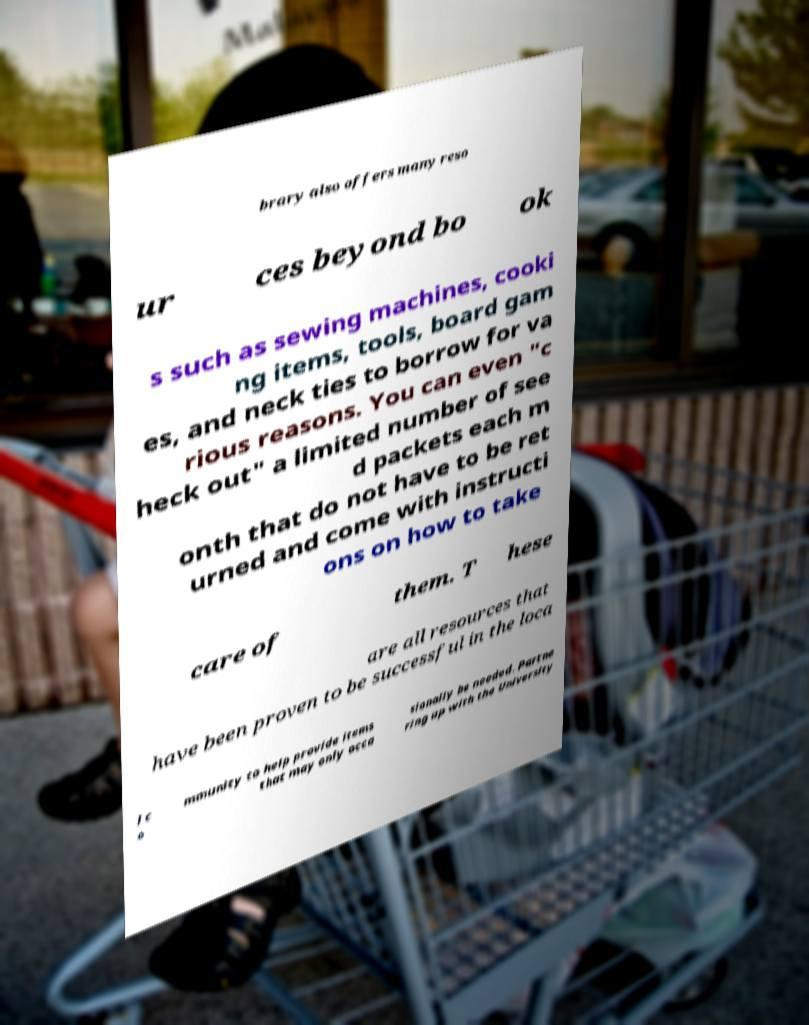I need the written content from this picture converted into text. Can you do that? brary also offers many reso ur ces beyond bo ok s such as sewing machines, cooki ng items, tools, board gam es, and neck ties to borrow for va rious reasons. You can even "c heck out" a limited number of see d packets each m onth that do not have to be ret urned and come with instructi ons on how to take care of them. T hese are all resources that have been proven to be successful in the loca l c o mmunity to help provide items that may only occa sionally be needed. Partne ring up with the University 